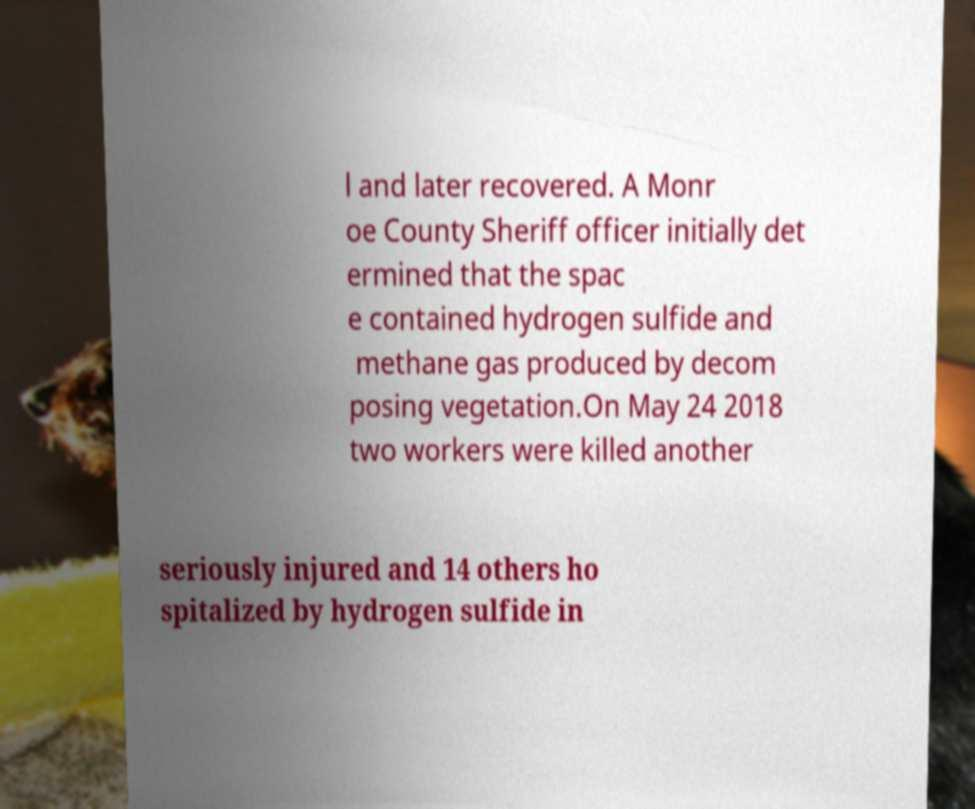There's text embedded in this image that I need extracted. Can you transcribe it verbatim? l and later recovered. A Monr oe County Sheriff officer initially det ermined that the spac e contained hydrogen sulfide and methane gas produced by decom posing vegetation.On May 24 2018 two workers were killed another seriously injured and 14 others ho spitalized by hydrogen sulfide in 